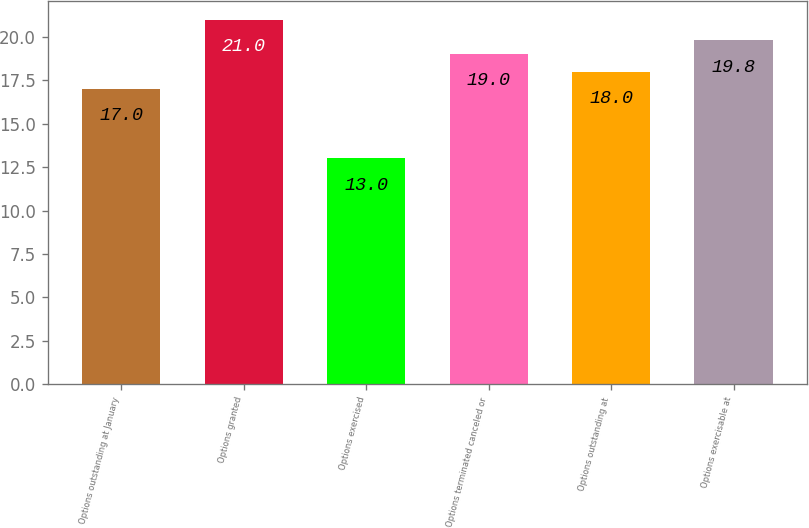<chart> <loc_0><loc_0><loc_500><loc_500><bar_chart><fcel>Options outstanding at January<fcel>Options granted<fcel>Options exercised<fcel>Options terminated canceled or<fcel>Options outstanding at<fcel>Options exercisable at<nl><fcel>17<fcel>21<fcel>13<fcel>19<fcel>18<fcel>19.8<nl></chart> 